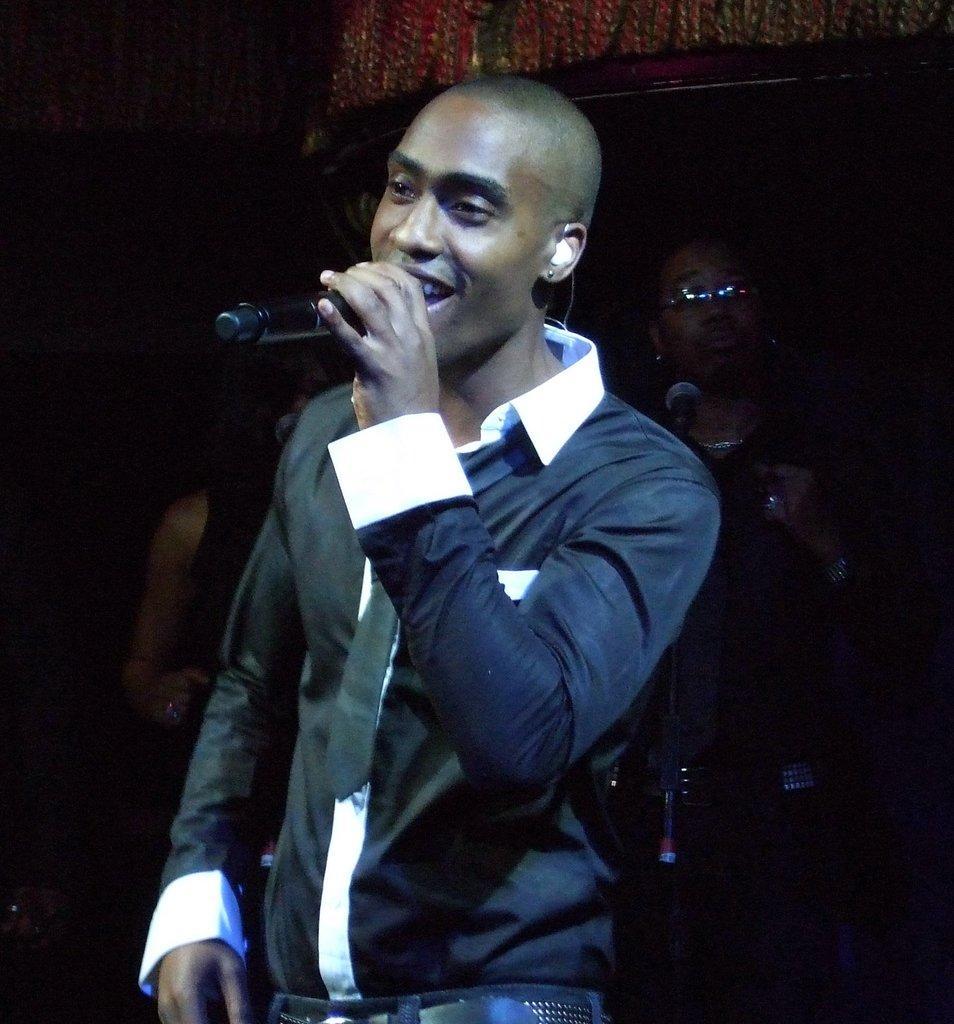Could you give a brief overview of what you see in this image? Here a man is standing and singing behind him there are few people. 